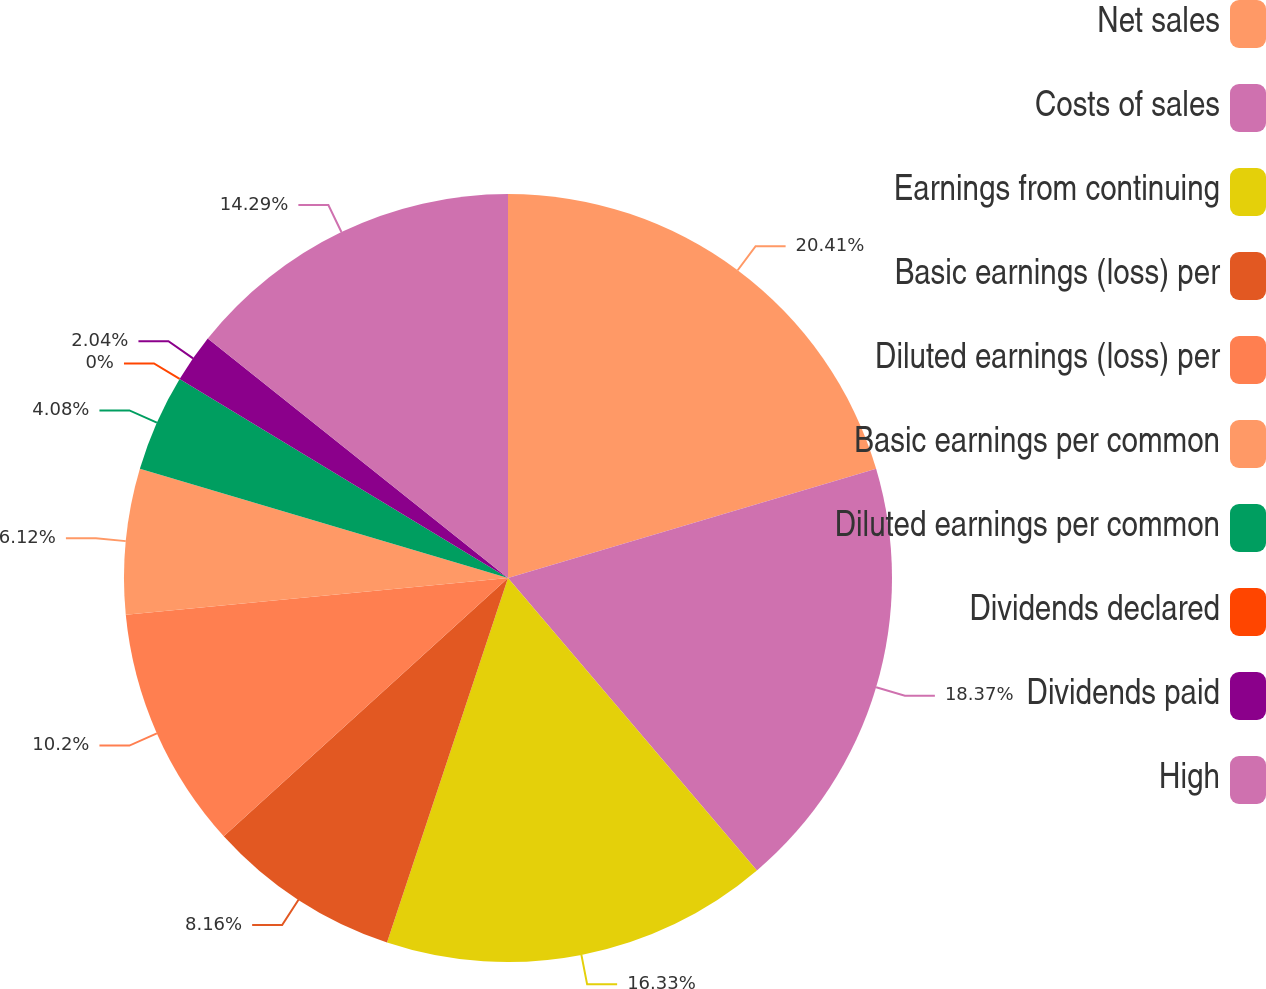Convert chart to OTSL. <chart><loc_0><loc_0><loc_500><loc_500><pie_chart><fcel>Net sales<fcel>Costs of sales<fcel>Earnings from continuing<fcel>Basic earnings (loss) per<fcel>Diluted earnings (loss) per<fcel>Basic earnings per common<fcel>Diluted earnings per common<fcel>Dividends declared<fcel>Dividends paid<fcel>High<nl><fcel>20.4%<fcel>18.36%<fcel>16.32%<fcel>8.16%<fcel>10.2%<fcel>6.12%<fcel>4.08%<fcel>0.0%<fcel>2.04%<fcel>14.28%<nl></chart> 